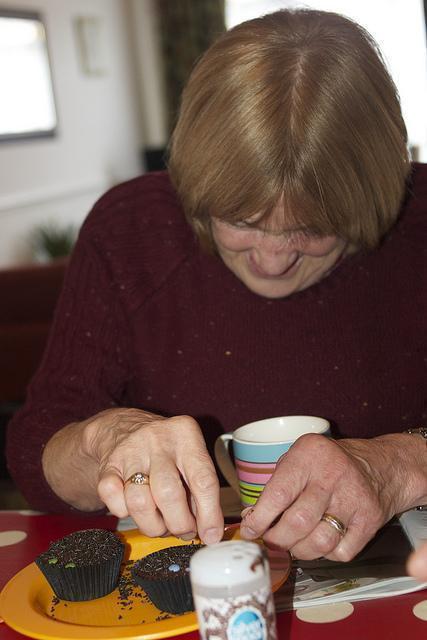Is the caption "The tv is behind the person." a true representation of the image?
Answer yes or no. Yes. 